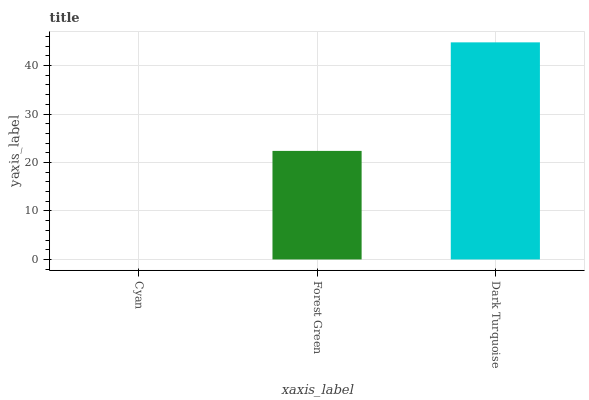Is Cyan the minimum?
Answer yes or no. Yes. Is Dark Turquoise the maximum?
Answer yes or no. Yes. Is Forest Green the minimum?
Answer yes or no. No. Is Forest Green the maximum?
Answer yes or no. No. Is Forest Green greater than Cyan?
Answer yes or no. Yes. Is Cyan less than Forest Green?
Answer yes or no. Yes. Is Cyan greater than Forest Green?
Answer yes or no. No. Is Forest Green less than Cyan?
Answer yes or no. No. Is Forest Green the high median?
Answer yes or no. Yes. Is Forest Green the low median?
Answer yes or no. Yes. Is Cyan the high median?
Answer yes or no. No. Is Dark Turquoise the low median?
Answer yes or no. No. 